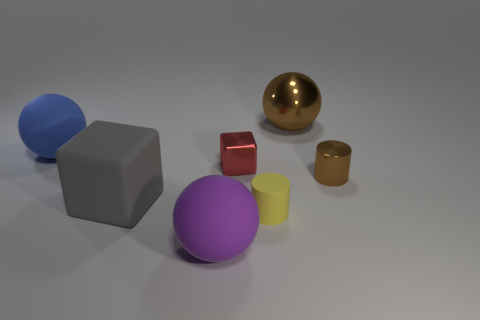Subtract all matte balls. How many balls are left? 1 Subtract all red cubes. How many cubes are left? 1 Subtract all spheres. How many objects are left? 4 Add 6 small blocks. How many small blocks exist? 7 Add 2 tiny matte cylinders. How many objects exist? 9 Subtract 0 purple cylinders. How many objects are left? 7 Subtract all green cylinders. Subtract all red balls. How many cylinders are left? 2 Subtract all purple spheres. How many gray blocks are left? 1 Subtract all small red cubes. Subtract all purple things. How many objects are left? 5 Add 1 small yellow cylinders. How many small yellow cylinders are left? 2 